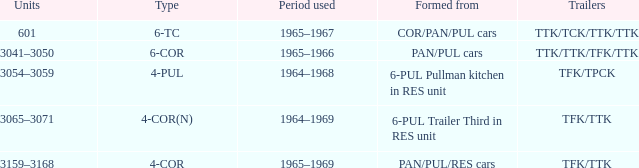Name the trailers for formed from pan/pul/res cars TFK/TTK. 